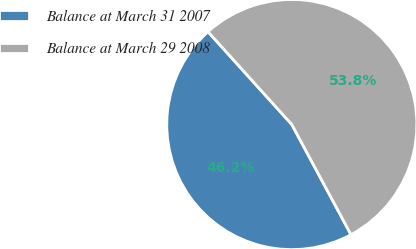Convert chart. <chart><loc_0><loc_0><loc_500><loc_500><pie_chart><fcel>Balance at March 31 2007<fcel>Balance at March 29 2008<nl><fcel>46.16%<fcel>53.84%<nl></chart> 